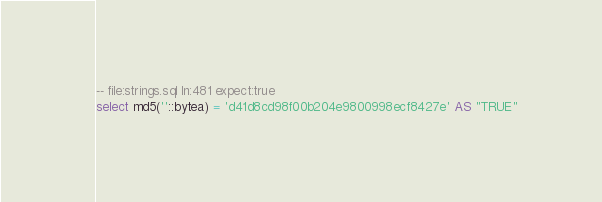<code> <loc_0><loc_0><loc_500><loc_500><_SQL_>-- file:strings.sql ln:481 expect:true
select md5(''::bytea) = 'd41d8cd98f00b204e9800998ecf8427e' AS "TRUE"
</code> 